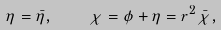Convert formula to latex. <formula><loc_0><loc_0><loc_500><loc_500>\eta = \bar { \eta } , \quad \chi = \phi + \eta = r ^ { 2 } \bar { \chi } ,</formula> 